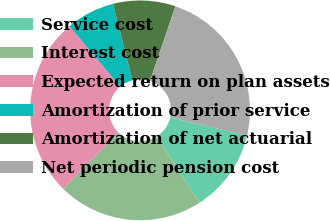Convert chart to OTSL. <chart><loc_0><loc_0><loc_500><loc_500><pie_chart><fcel>Service cost<fcel>Interest cost<fcel>Expected return on plan assets<fcel>Amortization of prior service<fcel>Amortization of net actuarial<fcel>Net periodic pension cost<nl><fcel>12.24%<fcel>21.43%<fcel>26.53%<fcel>7.14%<fcel>9.18%<fcel>23.47%<nl></chart> 